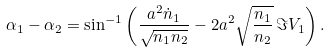Convert formula to latex. <formula><loc_0><loc_0><loc_500><loc_500>\alpha _ { 1 } - \alpha _ { 2 } = \sin ^ { - 1 } \left ( \frac { a ^ { 2 } \dot { n } _ { 1 } } { \sqrt { n _ { 1 } n _ { 2 } } } - 2 a ^ { 2 } \sqrt { \frac { n _ { 1 } } { n _ { 2 } } } \, \Im V _ { 1 } \right ) .</formula> 